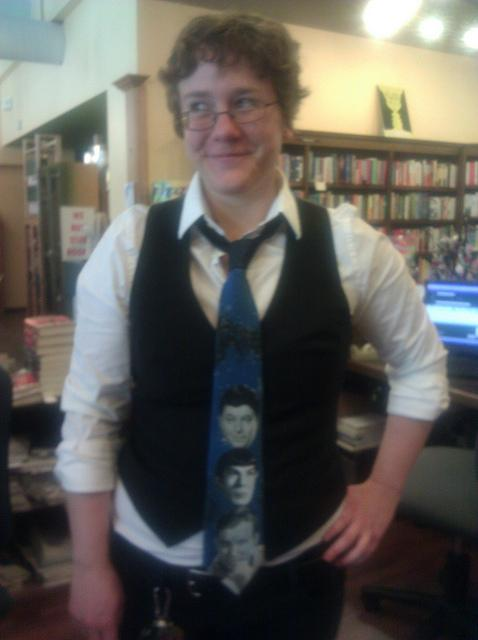What type of shop is the person wearing the tie in? Please explain your reasoning. book store. You can tell by all of the bookshelves as to where the photo was taken. 